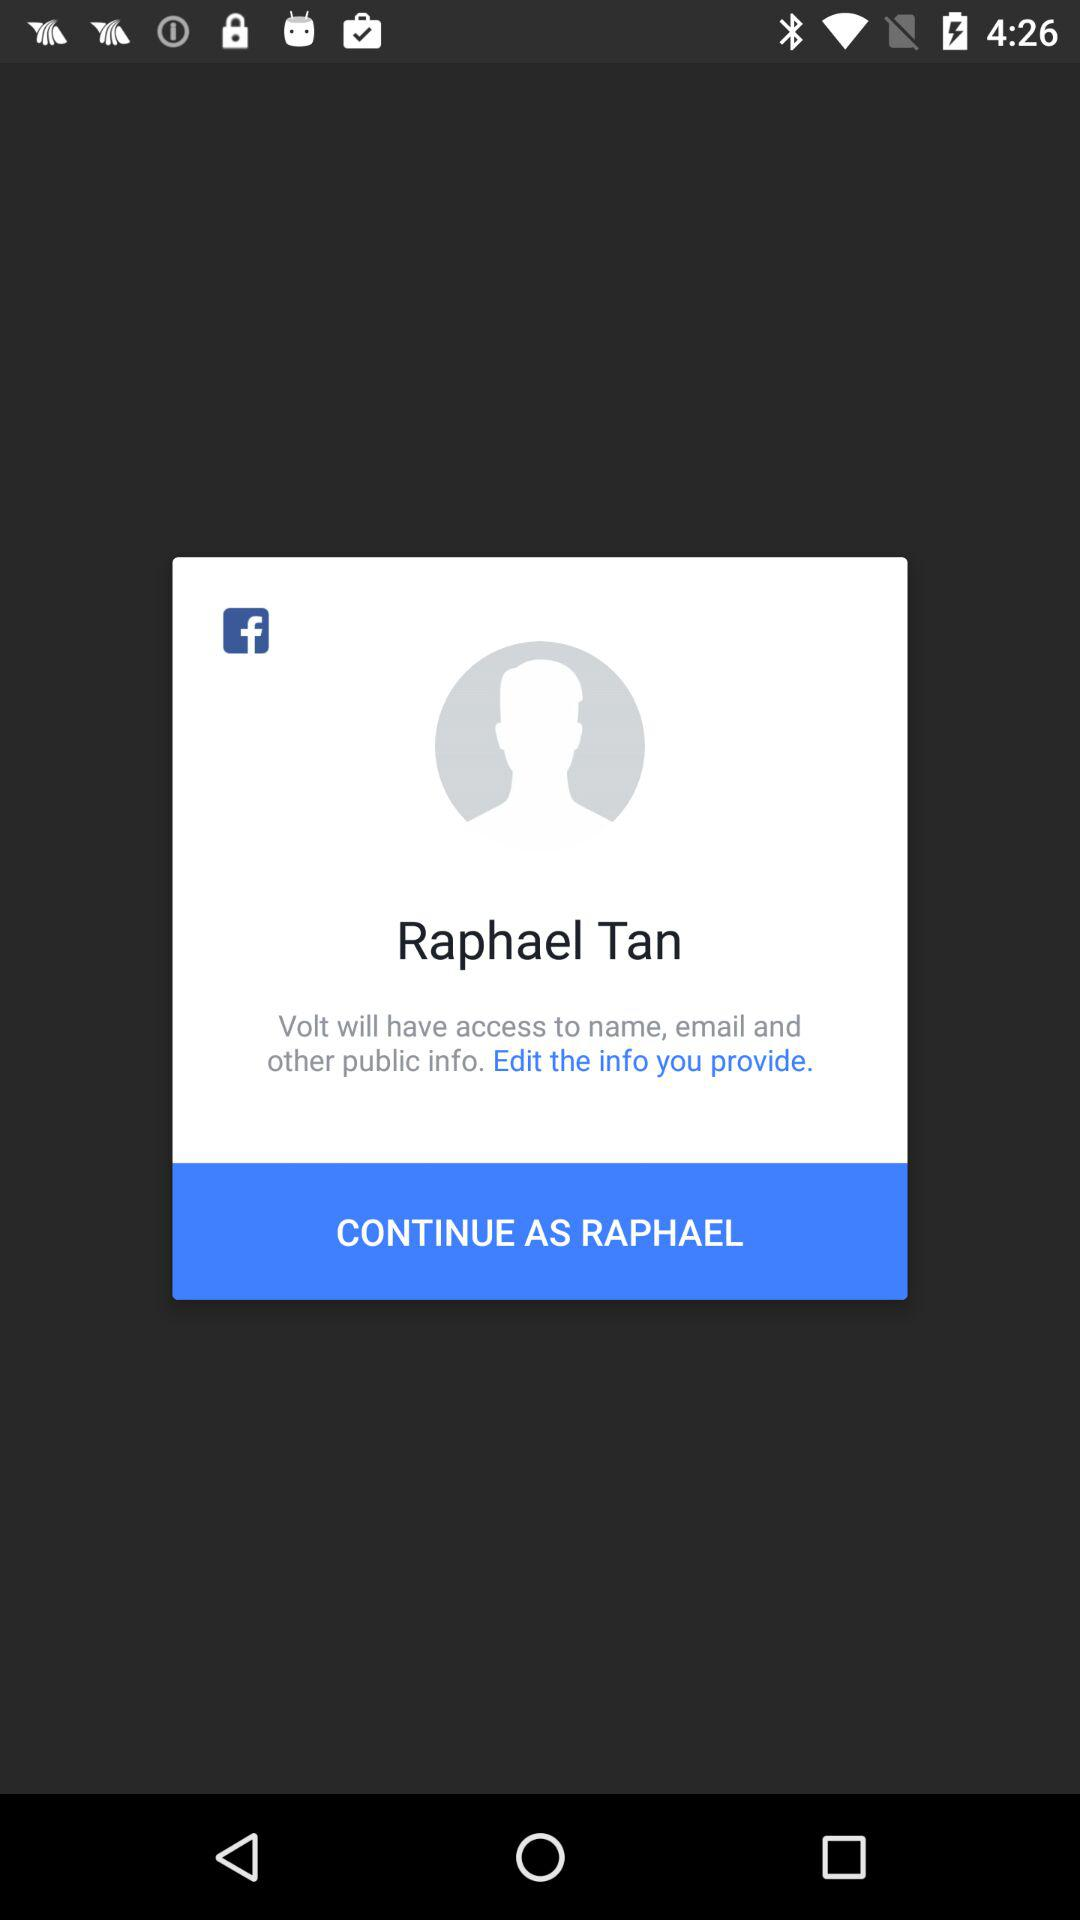How many types of information will Volt have access to?
Answer the question using a single word or phrase. 3 